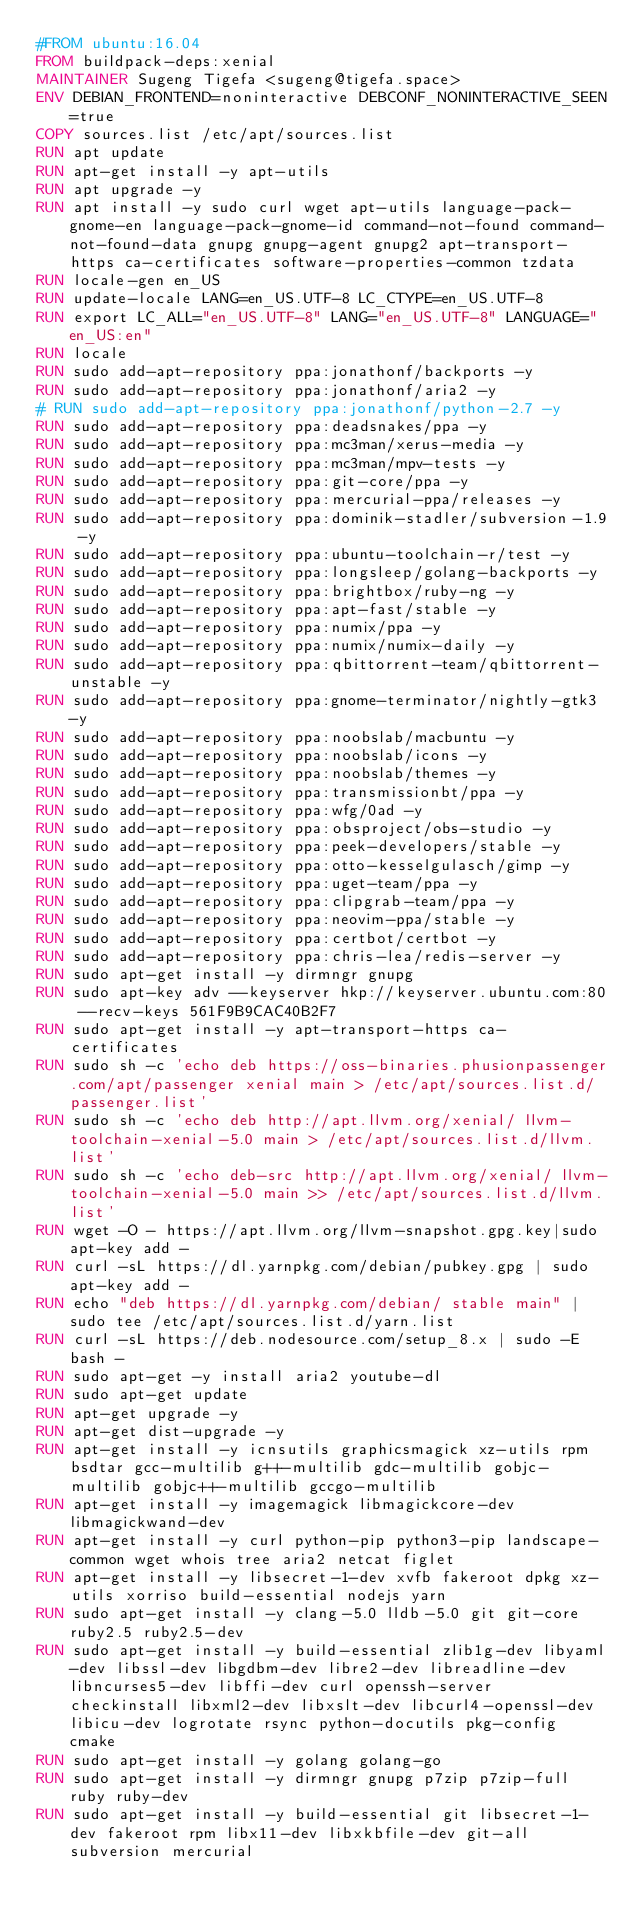Convert code to text. <code><loc_0><loc_0><loc_500><loc_500><_Dockerfile_>#FROM ubuntu:16.04
FROM buildpack-deps:xenial
MAINTAINER Sugeng Tigefa <sugeng@tigefa.space>
ENV DEBIAN_FRONTEND=noninteractive DEBCONF_NONINTERACTIVE_SEEN=true
COPY sources.list /etc/apt/sources.list
RUN apt update
RUN apt-get install -y apt-utils
RUN apt upgrade -y
RUN apt install -y sudo curl wget apt-utils language-pack-gnome-en language-pack-gnome-id command-not-found command-not-found-data gnupg gnupg-agent gnupg2 apt-transport-https ca-certificates software-properties-common tzdata
RUN locale-gen en_US
RUN update-locale LANG=en_US.UTF-8 LC_CTYPE=en_US.UTF-8
RUN export LC_ALL="en_US.UTF-8" LANG="en_US.UTF-8" LANGUAGE="en_US:en"
RUN locale
RUN sudo add-apt-repository ppa:jonathonf/backports -y
RUN sudo add-apt-repository ppa:jonathonf/aria2 -y
# RUN sudo add-apt-repository ppa:jonathonf/python-2.7 -y
RUN sudo add-apt-repository ppa:deadsnakes/ppa -y
RUN sudo add-apt-repository ppa:mc3man/xerus-media -y
RUN sudo add-apt-repository ppa:mc3man/mpv-tests -y
RUN sudo add-apt-repository ppa:git-core/ppa -y
RUN sudo add-apt-repository ppa:mercurial-ppa/releases -y
RUN sudo add-apt-repository ppa:dominik-stadler/subversion-1.9 -y
RUN sudo add-apt-repository ppa:ubuntu-toolchain-r/test -y
RUN sudo add-apt-repository ppa:longsleep/golang-backports -y
RUN sudo add-apt-repository ppa:brightbox/ruby-ng -y
RUN sudo add-apt-repository ppa:apt-fast/stable -y
RUN sudo add-apt-repository ppa:numix/ppa -y
RUN sudo add-apt-repository ppa:numix/numix-daily -y
RUN sudo add-apt-repository ppa:qbittorrent-team/qbittorrent-unstable -y
RUN sudo add-apt-repository ppa:gnome-terminator/nightly-gtk3 -y
RUN sudo add-apt-repository ppa:noobslab/macbuntu -y
RUN sudo add-apt-repository ppa:noobslab/icons -y
RUN sudo add-apt-repository ppa:noobslab/themes -y
RUN sudo add-apt-repository ppa:transmissionbt/ppa -y
RUN sudo add-apt-repository ppa:wfg/0ad -y
RUN sudo add-apt-repository ppa:obsproject/obs-studio -y
RUN sudo add-apt-repository ppa:peek-developers/stable -y
RUN sudo add-apt-repository ppa:otto-kesselgulasch/gimp -y
RUN sudo add-apt-repository ppa:uget-team/ppa -y
RUN sudo add-apt-repository ppa:clipgrab-team/ppa -y
RUN sudo add-apt-repository ppa:neovim-ppa/stable -y
RUN sudo add-apt-repository ppa:certbot/certbot -y
RUN sudo add-apt-repository ppa:chris-lea/redis-server -y
RUN sudo apt-get install -y dirmngr gnupg
RUN sudo apt-key adv --keyserver hkp://keyserver.ubuntu.com:80 --recv-keys 561F9B9CAC40B2F7
RUN sudo apt-get install -y apt-transport-https ca-certificates
RUN sudo sh -c 'echo deb https://oss-binaries.phusionpassenger.com/apt/passenger xenial main > /etc/apt/sources.list.d/passenger.list'
RUN sudo sh -c 'echo deb http://apt.llvm.org/xenial/ llvm-toolchain-xenial-5.0 main > /etc/apt/sources.list.d/llvm.list'
RUN sudo sh -c 'echo deb-src http://apt.llvm.org/xenial/ llvm-toolchain-xenial-5.0 main >> /etc/apt/sources.list.d/llvm.list'
RUN wget -O - https://apt.llvm.org/llvm-snapshot.gpg.key|sudo apt-key add -
RUN curl -sL https://dl.yarnpkg.com/debian/pubkey.gpg | sudo apt-key add -
RUN echo "deb https://dl.yarnpkg.com/debian/ stable main" | sudo tee /etc/apt/sources.list.d/yarn.list
RUN curl -sL https://deb.nodesource.com/setup_8.x | sudo -E bash -
RUN sudo apt-get -y install aria2 youtube-dl
RUN sudo apt-get update
RUN apt-get upgrade -y
RUN apt-get dist-upgrade -y
RUN apt-get install -y icnsutils graphicsmagick xz-utils rpm bsdtar gcc-multilib g++-multilib gdc-multilib gobjc-multilib gobjc++-multilib gccgo-multilib
RUN apt-get install -y imagemagick libmagickcore-dev libmagickwand-dev
RUN apt-get install -y curl python-pip python3-pip landscape-common wget whois tree aria2 netcat figlet
RUN apt-get install -y libsecret-1-dev xvfb fakeroot dpkg xz-utils xorriso build-essential nodejs yarn
RUN sudo apt-get install -y clang-5.0 lldb-5.0 git git-core ruby2.5 ruby2.5-dev
RUN sudo apt-get install -y build-essential zlib1g-dev libyaml-dev libssl-dev libgdbm-dev libre2-dev libreadline-dev libncurses5-dev libffi-dev curl openssh-server checkinstall libxml2-dev libxslt-dev libcurl4-openssl-dev libicu-dev logrotate rsync python-docutils pkg-config cmake
RUN sudo apt-get install -y golang golang-go 
RUN sudo apt-get install -y dirmngr gnupg p7zip p7zip-full ruby ruby-dev
RUN sudo apt-get install -y build-essential git libsecret-1-dev fakeroot rpm libx11-dev libxkbfile-dev git-all subversion mercurial</code> 